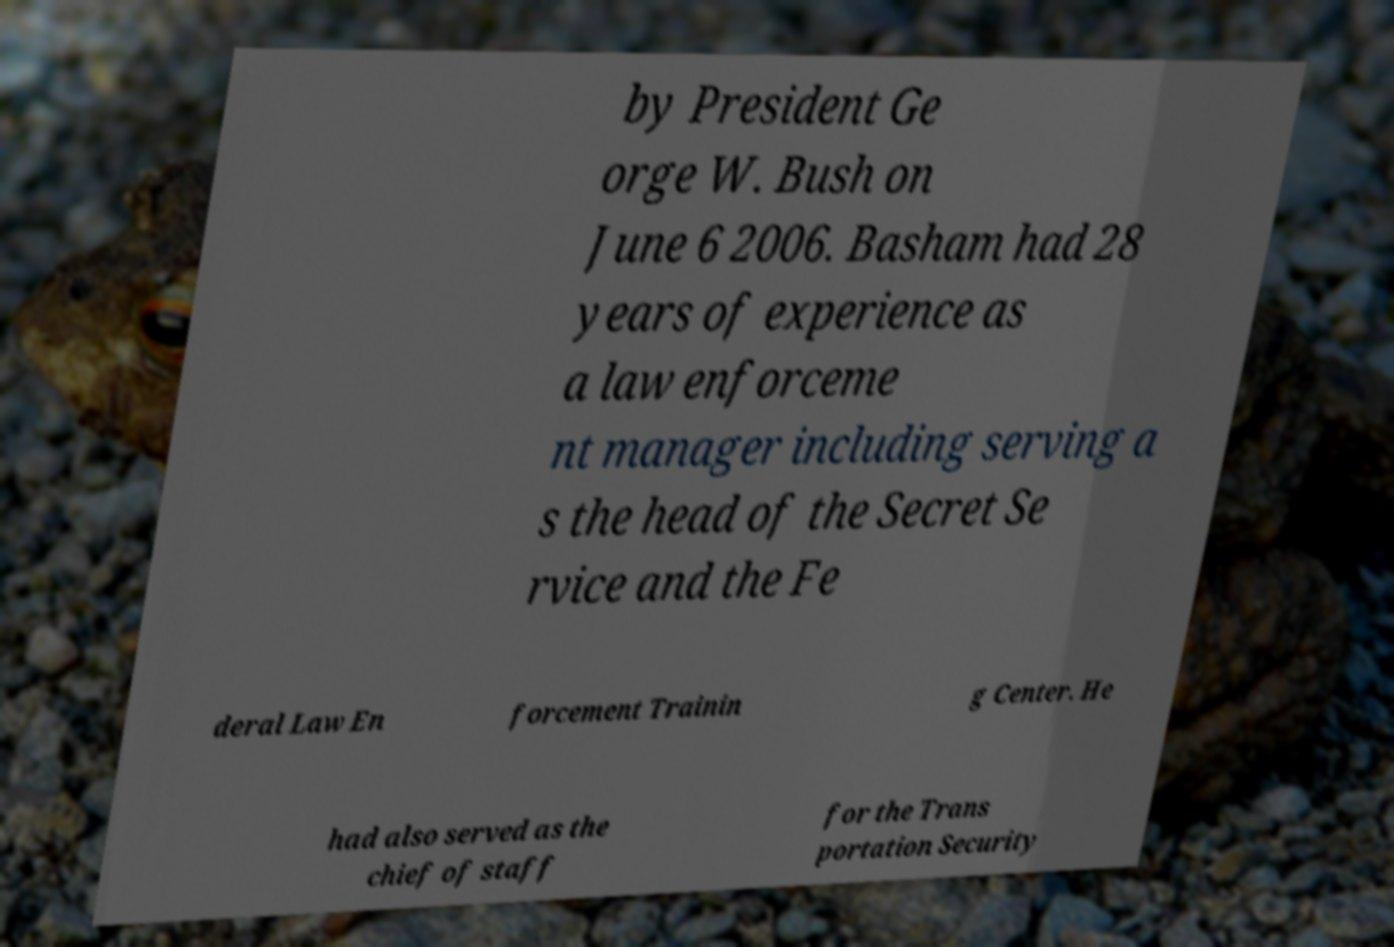Please read and relay the text visible in this image. What does it say? by President Ge orge W. Bush on June 6 2006. Basham had 28 years of experience as a law enforceme nt manager including serving a s the head of the Secret Se rvice and the Fe deral Law En forcement Trainin g Center. He had also served as the chief of staff for the Trans portation Security 